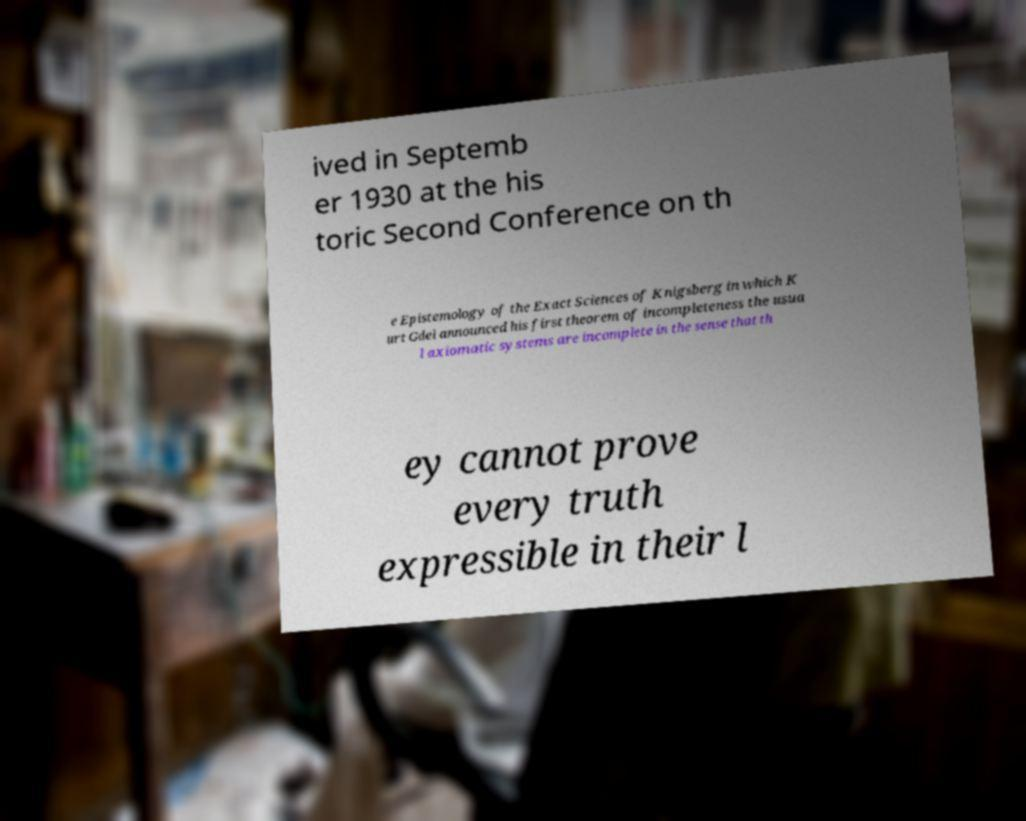I need the written content from this picture converted into text. Can you do that? ived in Septemb er 1930 at the his toric Second Conference on th e Epistemology of the Exact Sciences of Knigsberg in which K urt Gdel announced his first theorem of incompleteness the usua l axiomatic systems are incomplete in the sense that th ey cannot prove every truth expressible in their l 